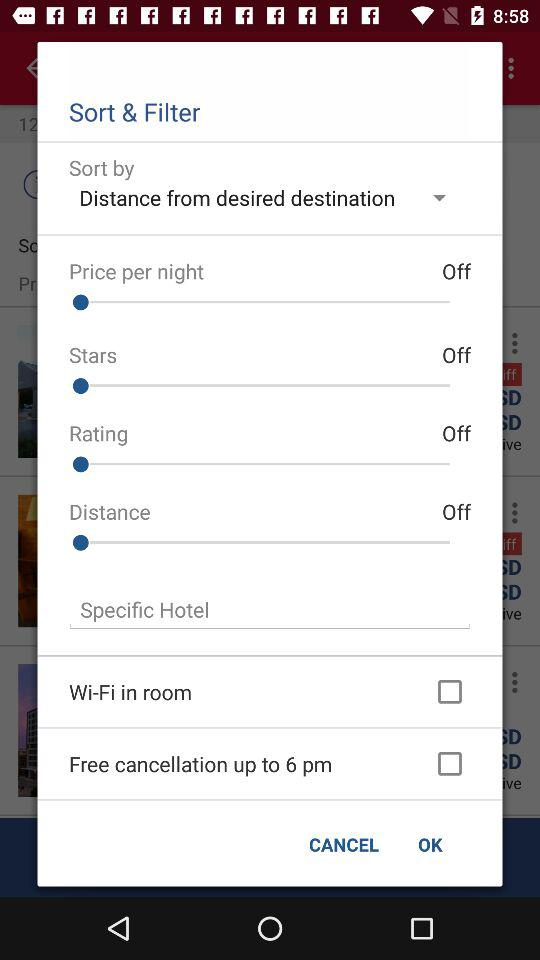What is the current status of "Wi-Fi in room"? The status is "off". 